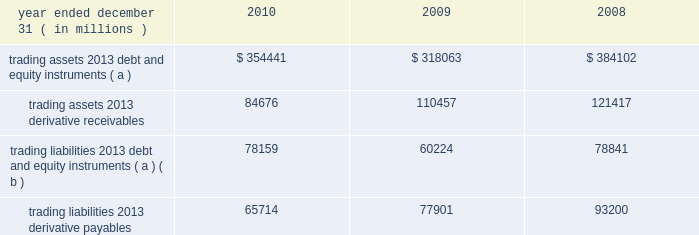Jpmorgan chase & co./2010 annual report 187 trading assets and liabilities trading assets include debt and equity instruments held for trading purposes that jpmorgan chase owns ( 201clong 201d positions ) , certain loans managed on a fair value basis and for which the firm has elected the fair value option , and physical commodities inventories that are generally accounted for at the lower of cost or fair value .
Trading liabilities include debt and equity instruments that the firm has sold to other parties but does not own ( 201cshort 201d positions ) .
The firm is obligated to purchase instruments at a future date to cover the short positions .
Included in trading assets and trading liabilities are the reported receivables ( unrealized gains ) and payables ( unre- alized losses ) related to derivatives .
Trading assets and liabilities are carried at fair value on the consolidated balance sheets .
Bal- ances reflect the reduction of securities owned ( long positions ) by the amount of securities sold but not yet purchased ( short posi- tions ) when the long and short positions have identical committee on uniform security identification procedures ( 201ccusips 201d ) .
Trading assets and liabilities 2013average balances average trading assets and liabilities were as follows for the periods indicated. .
( a ) balances reflect the reduction of securities owned ( long positions ) by the amount of securities sold , but not yet purchased ( short positions ) when the long and short positions have identical cusips .
( b ) primarily represent securities sold , not yet purchased .
Note 4 2013 fair value option the fair value option provides an option to elect fair value as an alternative measurement for selected financial assets , financial liabilities , unrecognized firm commitments , and written loan com- mitments not previously carried at fair value .
Elections elections were made by the firm to : 2022 mitigate income statement volatility caused by the differences in the measurement basis of elected instruments ( for example , cer- tain instruments elected were previously accounted for on an accrual basis ) while the associated risk management arrange- ments are accounted for on a fair value basis ; 2022 eliminate the complexities of applying certain accounting models ( e.g. , hedge accounting or bifurcation accounting for hybrid in- struments ) ; and 2022 better reflect those instruments that are managed on a fair value basis .
Elections include the following : 2022 loans purchased or originated as part of securitization ware- housing activity , subject to bifurcation accounting , or man- aged on a fair value basis .
2022 securities financing arrangements with an embedded deriva- tive and/or a maturity of greater than one year .
2022 owned beneficial interests in securitized financial assets that contain embedded credit derivatives , which would otherwise be required to be separately accounted for as a derivative in- strument .
2022 certain tax credits and other equity investments acquired as part of the washington mutual transaction .
2022 structured notes issued as part of ib 2019s client-driven activities .
( structured notes are financial instruments that contain em- bedded derivatives. ) 2022 long-term beneficial interests issued by ib 2019s consolidated securitization trusts where the underlying assets are carried at fair value. .
In 2010 what was the ratio of the trading assets 2013 derivative receivables to the derivative payables? 
Computations: (84676 / 65714)
Answer: 1.28855. 